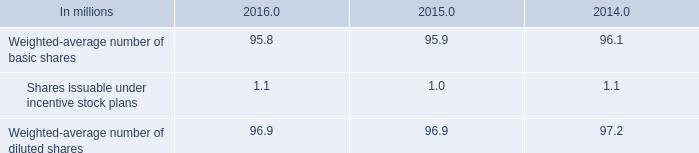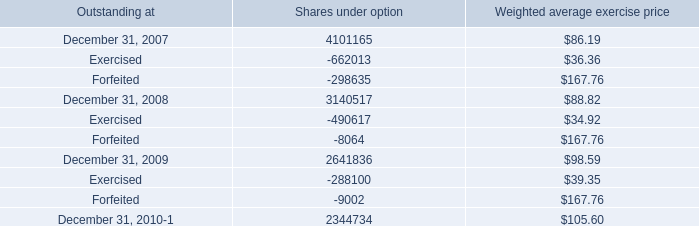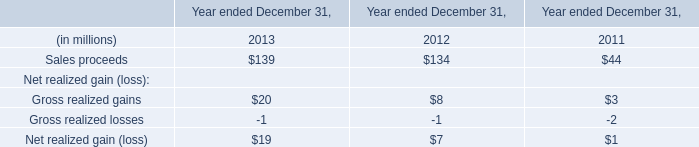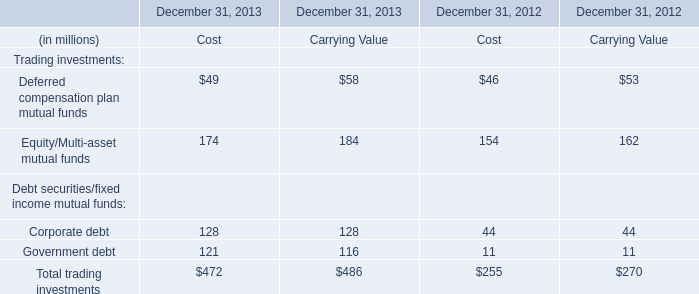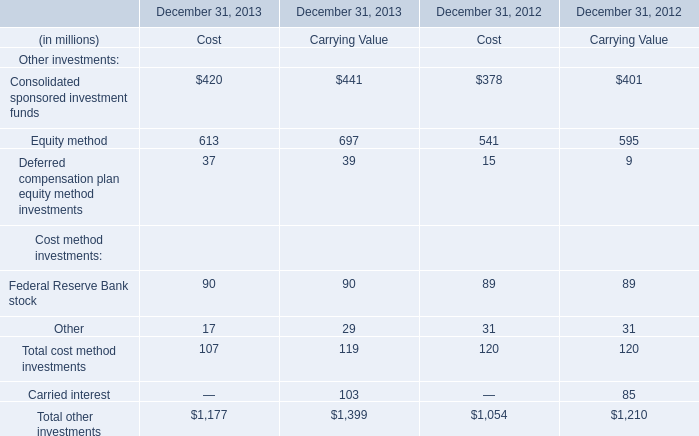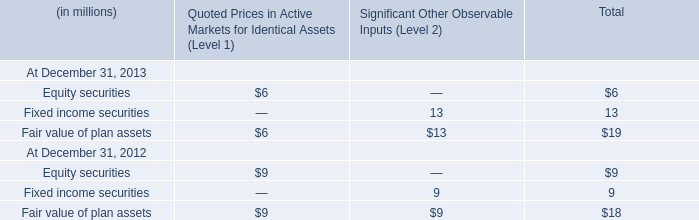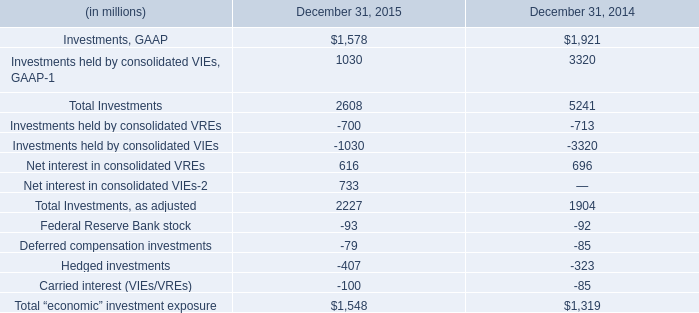In what year is Sales proceeds greater than 136? 
Answer: 2013. 